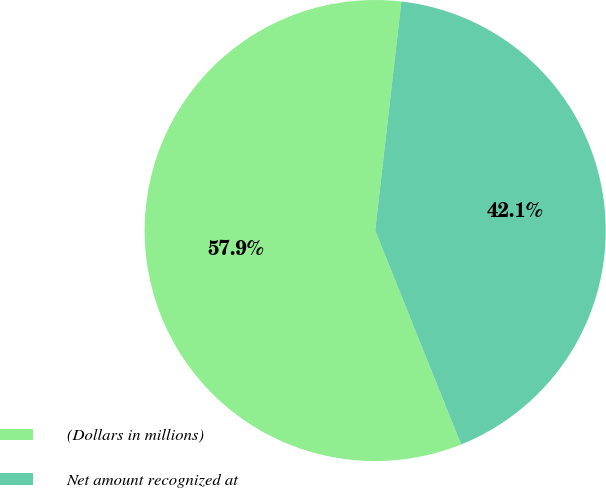Convert chart to OTSL. <chart><loc_0><loc_0><loc_500><loc_500><pie_chart><fcel>(Dollars in millions)<fcel>Net amount recognized at<nl><fcel>57.89%<fcel>42.11%<nl></chart> 